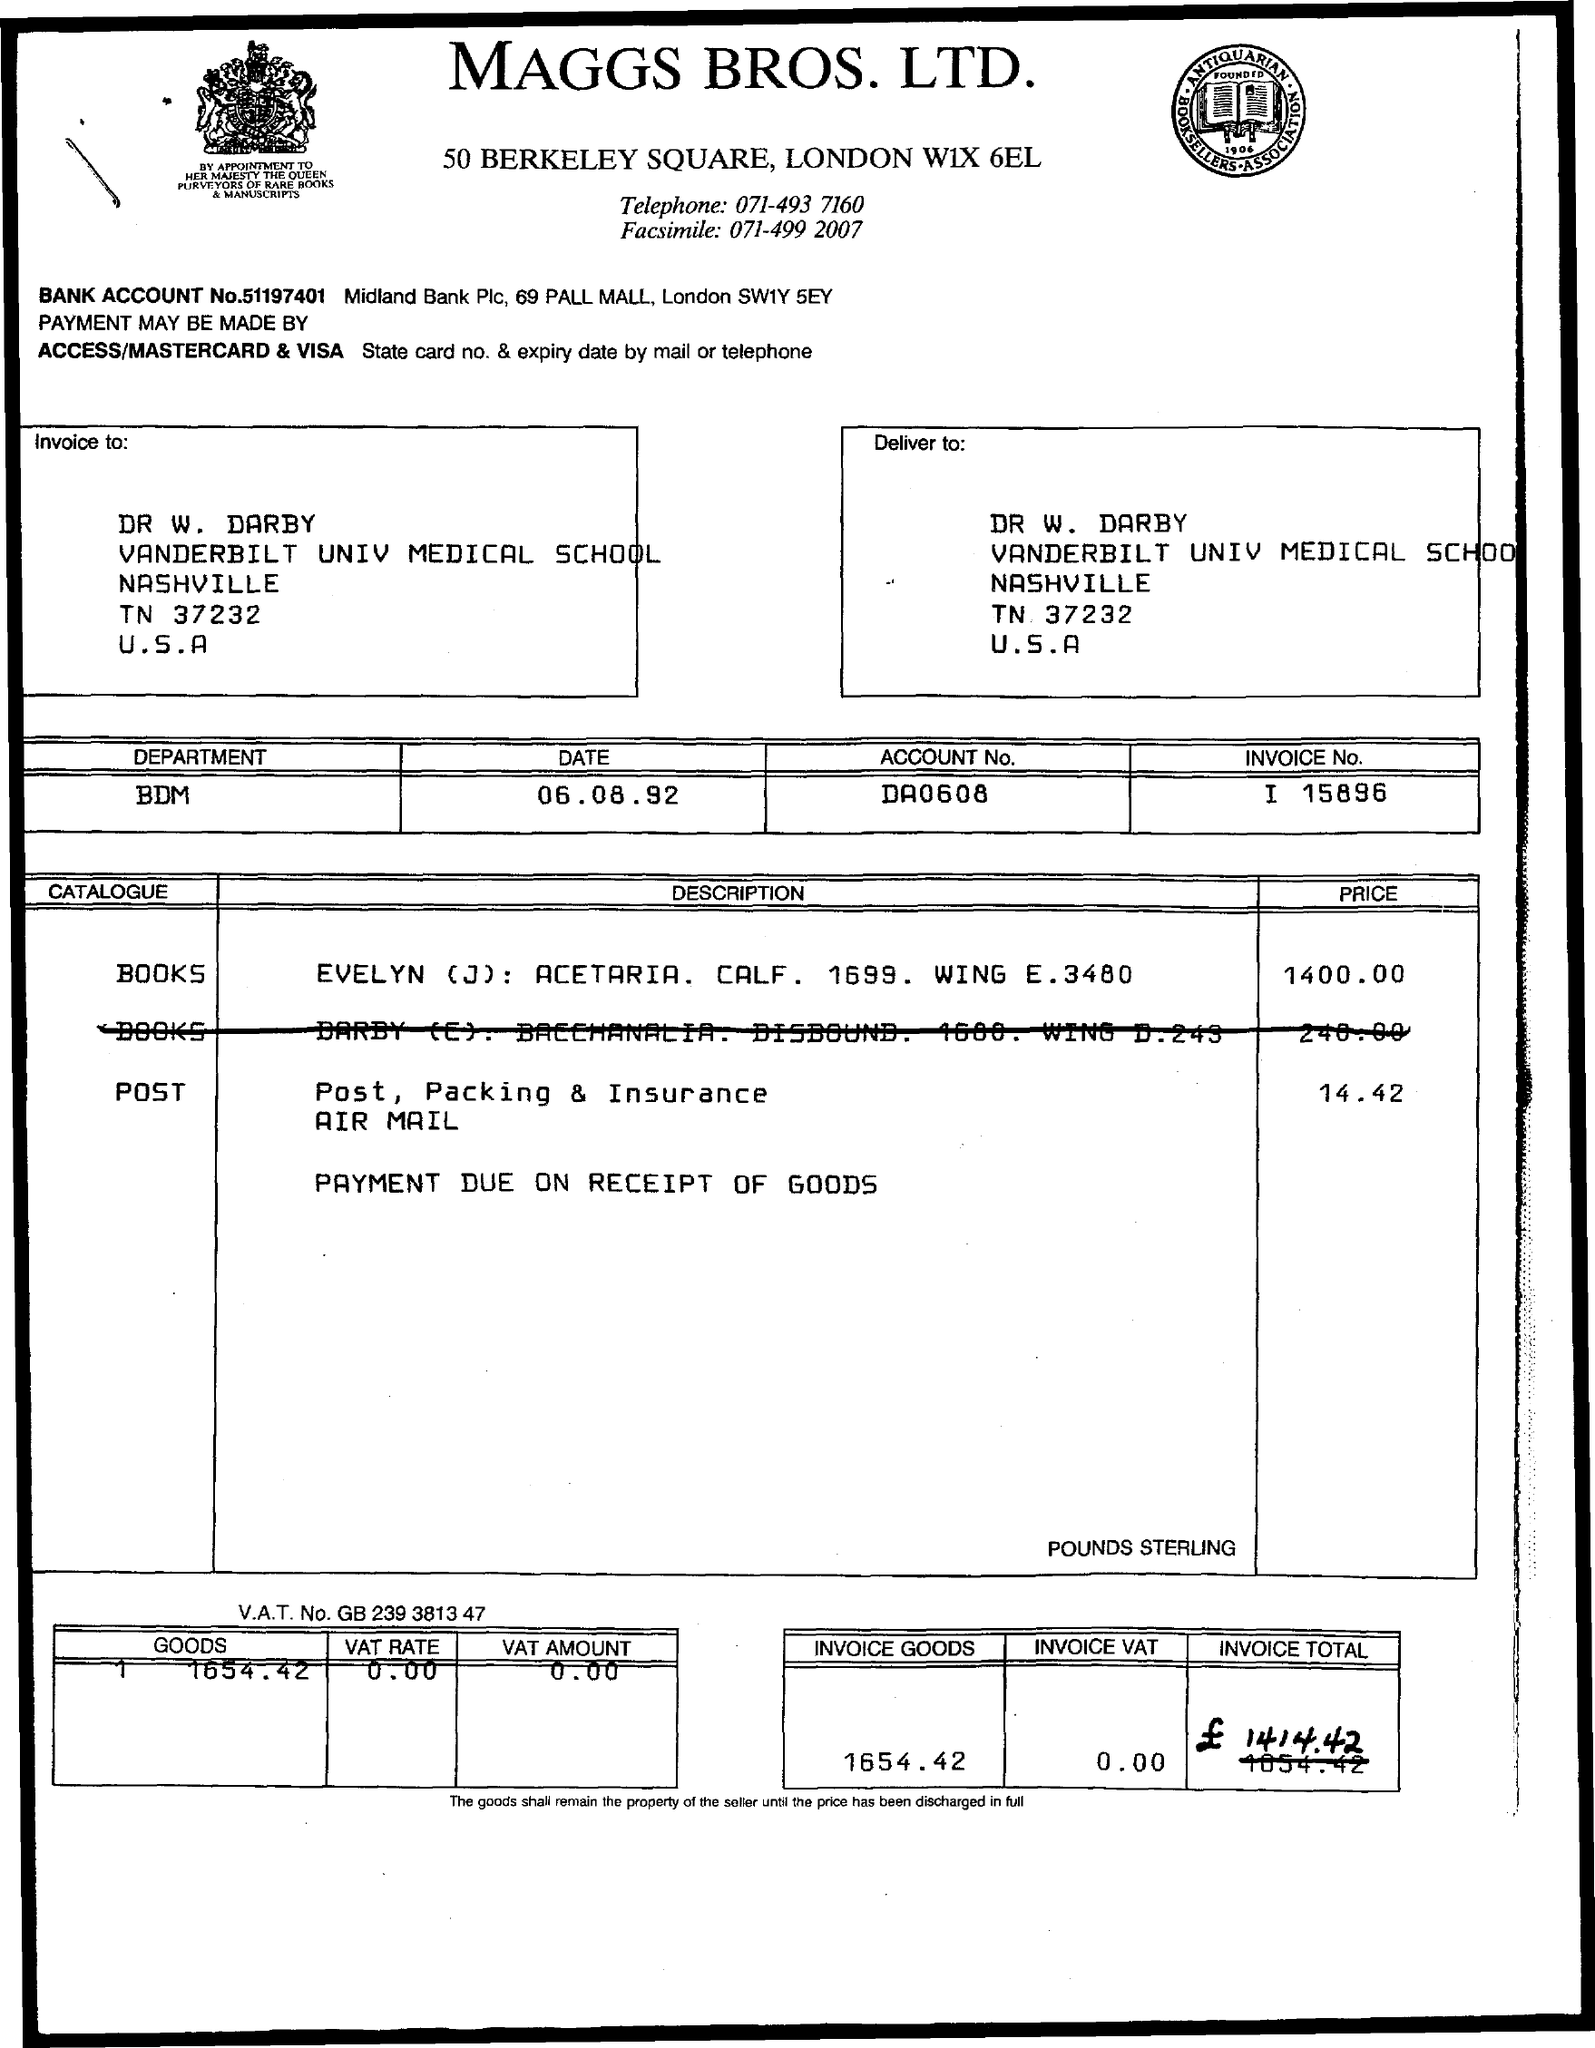What is the title of the document?
Your response must be concise. Maggs bros, ltd. What is the Account Number?
Make the answer very short. Da0608. What is the price of the post?
Your answer should be compact. 14.42. What is the VAT Amount?
Your answer should be very brief. 0.00. What is the VAT Rate?
Offer a terse response. 0.00. 